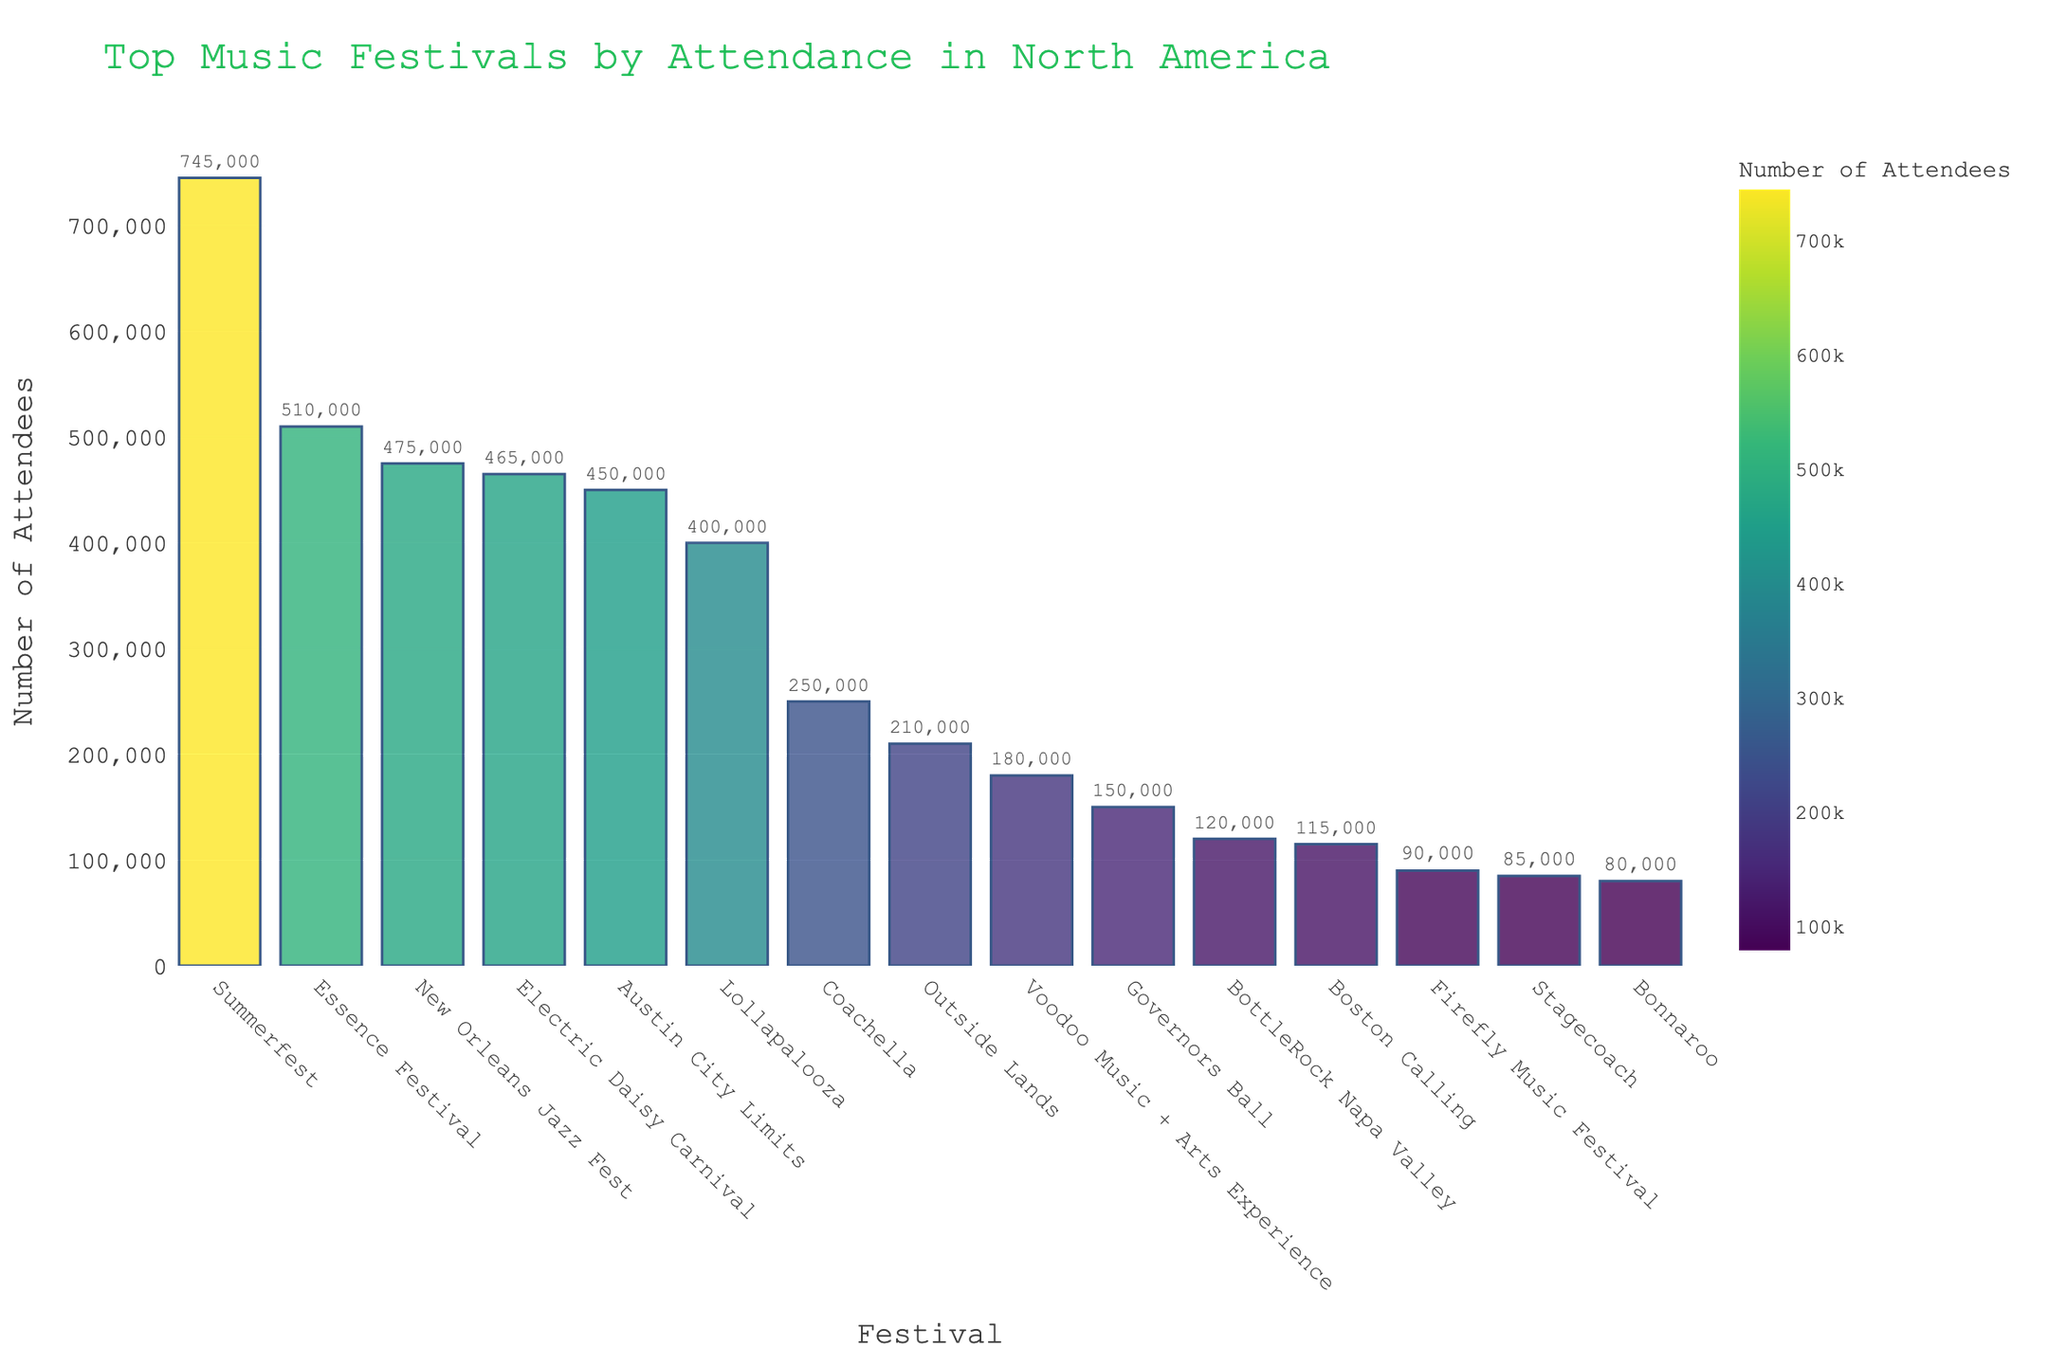Which festival has the highest attendance? The bar representing Summerfest is the tallest, thus it is the festival with the highest attendance.
Answer: Summerfest What is the total attendance for Coachella and Bonnaroo combined? Coachella has an attendance of 250,000 and Bonnaroo has 80,000. Summing them together: 250,000 + 80,000 = 330,000.
Answer: 330,000 How does the attendance of the Electric Daisy Carnival compare to the New Orleans Jazz Fest? The attendance of Electric Daisy Carnival is 465,000, whereas the New Orleans Jazz Fest has 475,000. Therefore, the New Orleans Jazz Fest has a slightly higher attendance by 10,000.
Answer: New Orleans Jazz Fest has 10,000 more What is the average attendance for the festivals listed? Add the attendances: 250,000 + 400,000 + 450,000 + 465,000 + 745,000 + 510,000 + 80,000 + 475,000 + 85,000 + 210,000 + 150,000 + 180,000 + 120,000 + 90,000 + 115,000 = 4,325,000. Divide by 15 (number of festivals): 4,325,000 / 15 = 288,333.33.
Answer: 288,333.33 Which festival has the lowest attendance and what is the value? The bar representing Bonnaroo is the shortest, indicating it has the lowest attendance at 80,000.
Answer: Bonnaroo, 80,000 How does the attendance of Essence Festival compare to Summerfest in terms of percentage? Essence Festival attendance is 510,000 and Summerfest is 745,000. The percentage is calculated as (510,000 / 745,000) * 100 ≈ 68.46%.
Answer: Approximately 68.46% What is the difference in attendance between Governors Ball and Outside Lands? Governors Ball has an attendance of 150,000 and Outside Lands has 210,000. The difference is 210,000 - 150,000 = 60,000.
Answer: 60,000 Between Boston Calling and BottleRock Napa Valley, which festival has higher attendance and by how much? Boston Calling has an attendance of 115,000 and BottleRock Napa Valley has 120,000. BottleRock Napa Valley has higher attendance by 120,000 - 115,000 = 5,000.
Answer: BottleRock Napa Valley by 5,000 Which festival is directly in between Voodoo Music + Arts Experience and Firefly Music Festival in terms of attendance? Voodoo Music + Arts Experience has 180,000 and Firefly Music Festival has 90,000 attendees. The festival with attendance in between those two is BottleRock Napa Valley with 120,000 attendees.
Answer: BottleRock Napa Valley What visual attribute is used to represent the attendance of each festival? The height of each bar in the chart visually represents the attendance values, with taller bars indicating higher attendance.
Answer: Height of bars 